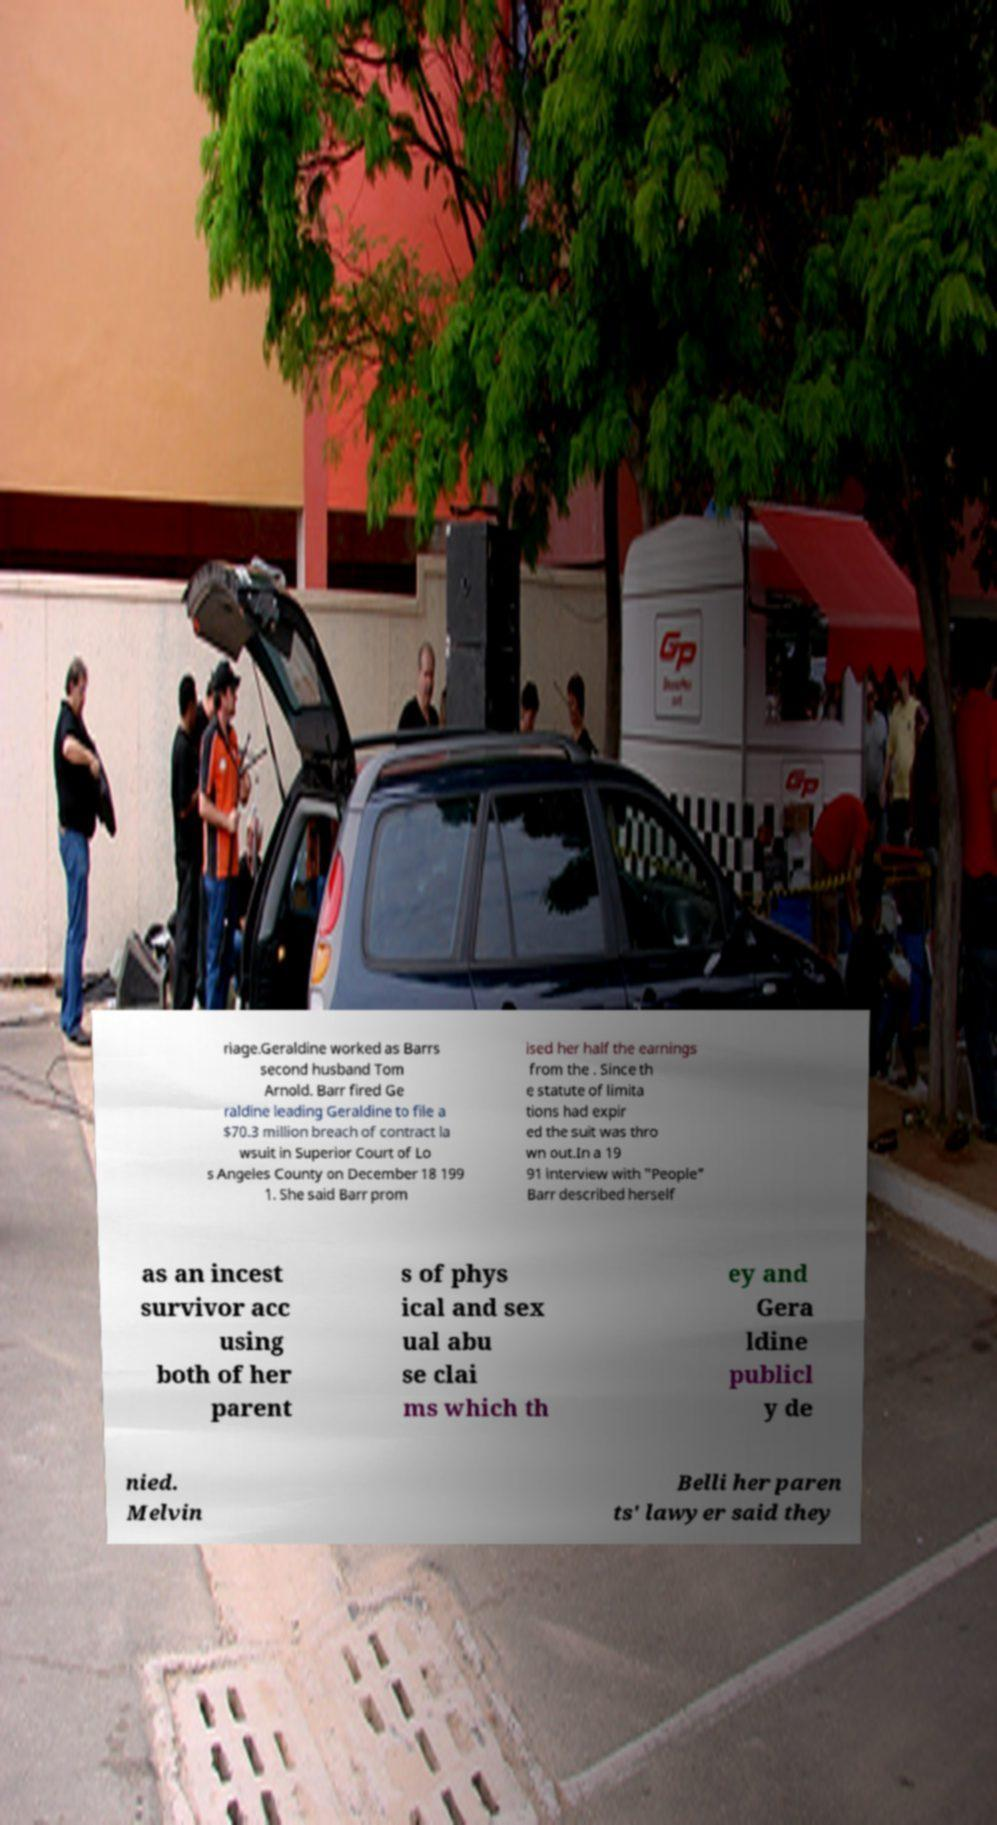Could you assist in decoding the text presented in this image and type it out clearly? riage.Geraldine worked as Barrs second husband Tom Arnold. Barr fired Ge raldine leading Geraldine to file a $70.3 million breach of contract la wsuit in Superior Court of Lo s Angeles County on December 18 199 1. She said Barr prom ised her half the earnings from the . Since th e statute of limita tions had expir ed the suit was thro wn out.In a 19 91 interview with "People" Barr described herself as an incest survivor acc using both of her parent s of phys ical and sex ual abu se clai ms which th ey and Gera ldine publicl y de nied. Melvin Belli her paren ts' lawyer said they 